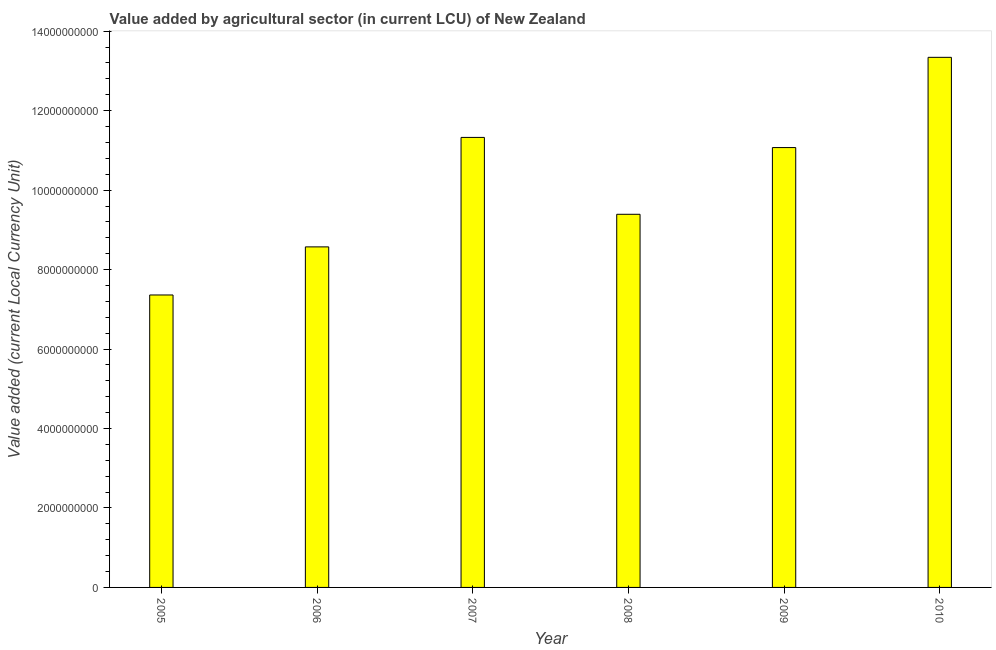Does the graph contain any zero values?
Provide a succinct answer. No. Does the graph contain grids?
Ensure brevity in your answer.  No. What is the title of the graph?
Your answer should be compact. Value added by agricultural sector (in current LCU) of New Zealand. What is the label or title of the X-axis?
Provide a short and direct response. Year. What is the label or title of the Y-axis?
Keep it short and to the point. Value added (current Local Currency Unit). What is the value added by agriculture sector in 2007?
Keep it short and to the point. 1.13e+1. Across all years, what is the maximum value added by agriculture sector?
Provide a short and direct response. 1.33e+1. Across all years, what is the minimum value added by agriculture sector?
Make the answer very short. 7.36e+09. In which year was the value added by agriculture sector maximum?
Keep it short and to the point. 2010. In which year was the value added by agriculture sector minimum?
Make the answer very short. 2005. What is the sum of the value added by agriculture sector?
Your response must be concise. 6.11e+1. What is the difference between the value added by agriculture sector in 2006 and 2008?
Provide a short and direct response. -8.20e+08. What is the average value added by agriculture sector per year?
Provide a succinct answer. 1.02e+1. What is the median value added by agriculture sector?
Provide a succinct answer. 1.02e+1. In how many years, is the value added by agriculture sector greater than 12800000000 LCU?
Make the answer very short. 1. What is the ratio of the value added by agriculture sector in 2005 to that in 2010?
Keep it short and to the point. 0.55. Is the difference between the value added by agriculture sector in 2007 and 2008 greater than the difference between any two years?
Keep it short and to the point. No. What is the difference between the highest and the second highest value added by agriculture sector?
Give a very brief answer. 2.02e+09. What is the difference between the highest and the lowest value added by agriculture sector?
Give a very brief answer. 5.98e+09. In how many years, is the value added by agriculture sector greater than the average value added by agriculture sector taken over all years?
Your answer should be compact. 3. How many bars are there?
Keep it short and to the point. 6. Are all the bars in the graph horizontal?
Give a very brief answer. No. What is the difference between two consecutive major ticks on the Y-axis?
Make the answer very short. 2.00e+09. Are the values on the major ticks of Y-axis written in scientific E-notation?
Provide a short and direct response. No. What is the Value added (current Local Currency Unit) of 2005?
Your answer should be very brief. 7.36e+09. What is the Value added (current Local Currency Unit) in 2006?
Your response must be concise. 8.57e+09. What is the Value added (current Local Currency Unit) of 2007?
Make the answer very short. 1.13e+1. What is the Value added (current Local Currency Unit) in 2008?
Ensure brevity in your answer.  9.39e+09. What is the Value added (current Local Currency Unit) of 2009?
Ensure brevity in your answer.  1.11e+1. What is the Value added (current Local Currency Unit) in 2010?
Give a very brief answer. 1.33e+1. What is the difference between the Value added (current Local Currency Unit) in 2005 and 2006?
Give a very brief answer. -1.21e+09. What is the difference between the Value added (current Local Currency Unit) in 2005 and 2007?
Provide a succinct answer. -3.97e+09. What is the difference between the Value added (current Local Currency Unit) in 2005 and 2008?
Provide a succinct answer. -2.03e+09. What is the difference between the Value added (current Local Currency Unit) in 2005 and 2009?
Offer a terse response. -3.71e+09. What is the difference between the Value added (current Local Currency Unit) in 2005 and 2010?
Your answer should be very brief. -5.98e+09. What is the difference between the Value added (current Local Currency Unit) in 2006 and 2007?
Your response must be concise. -2.76e+09. What is the difference between the Value added (current Local Currency Unit) in 2006 and 2008?
Make the answer very short. -8.20e+08. What is the difference between the Value added (current Local Currency Unit) in 2006 and 2009?
Make the answer very short. -2.50e+09. What is the difference between the Value added (current Local Currency Unit) in 2006 and 2010?
Your answer should be very brief. -4.77e+09. What is the difference between the Value added (current Local Currency Unit) in 2007 and 2008?
Ensure brevity in your answer.  1.94e+09. What is the difference between the Value added (current Local Currency Unit) in 2007 and 2009?
Offer a very short reply. 2.56e+08. What is the difference between the Value added (current Local Currency Unit) in 2007 and 2010?
Provide a short and direct response. -2.02e+09. What is the difference between the Value added (current Local Currency Unit) in 2008 and 2009?
Provide a short and direct response. -1.68e+09. What is the difference between the Value added (current Local Currency Unit) in 2008 and 2010?
Provide a succinct answer. -3.95e+09. What is the difference between the Value added (current Local Currency Unit) in 2009 and 2010?
Offer a very short reply. -2.27e+09. What is the ratio of the Value added (current Local Currency Unit) in 2005 to that in 2006?
Ensure brevity in your answer.  0.86. What is the ratio of the Value added (current Local Currency Unit) in 2005 to that in 2007?
Provide a succinct answer. 0.65. What is the ratio of the Value added (current Local Currency Unit) in 2005 to that in 2008?
Your answer should be compact. 0.78. What is the ratio of the Value added (current Local Currency Unit) in 2005 to that in 2009?
Keep it short and to the point. 0.67. What is the ratio of the Value added (current Local Currency Unit) in 2005 to that in 2010?
Make the answer very short. 0.55. What is the ratio of the Value added (current Local Currency Unit) in 2006 to that in 2007?
Offer a very short reply. 0.76. What is the ratio of the Value added (current Local Currency Unit) in 2006 to that in 2009?
Provide a short and direct response. 0.77. What is the ratio of the Value added (current Local Currency Unit) in 2006 to that in 2010?
Provide a short and direct response. 0.64. What is the ratio of the Value added (current Local Currency Unit) in 2007 to that in 2008?
Offer a terse response. 1.21. What is the ratio of the Value added (current Local Currency Unit) in 2007 to that in 2010?
Ensure brevity in your answer.  0.85. What is the ratio of the Value added (current Local Currency Unit) in 2008 to that in 2009?
Keep it short and to the point. 0.85. What is the ratio of the Value added (current Local Currency Unit) in 2008 to that in 2010?
Keep it short and to the point. 0.7. What is the ratio of the Value added (current Local Currency Unit) in 2009 to that in 2010?
Provide a short and direct response. 0.83. 